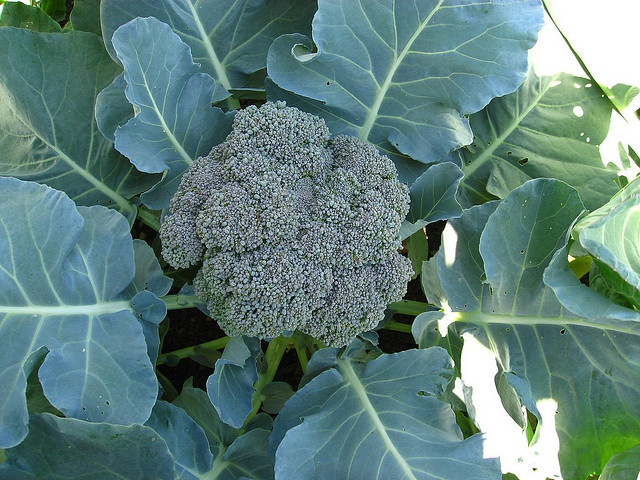Describe the objects in this image and their specific colors. I can see a broccoli in olive, gray, darkgray, and black tones in this image. 